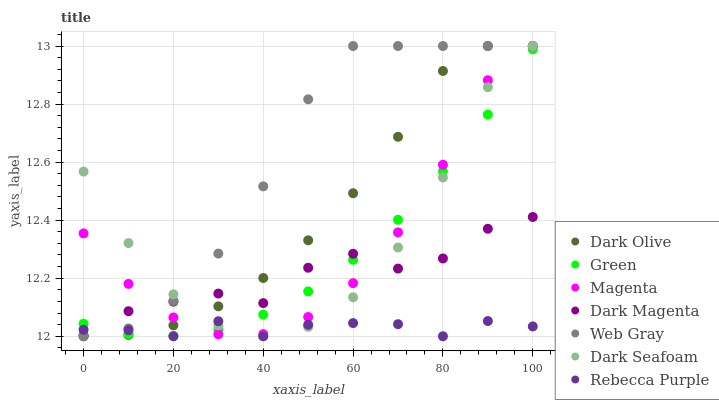Does Rebecca Purple have the minimum area under the curve?
Answer yes or no. Yes. Does Web Gray have the maximum area under the curve?
Answer yes or no. Yes. Does Dark Magenta have the minimum area under the curve?
Answer yes or no. No. Does Dark Magenta have the maximum area under the curve?
Answer yes or no. No. Is Green the smoothest?
Answer yes or no. Yes. Is Dark Seafoam the roughest?
Answer yes or no. Yes. Is Dark Magenta the smoothest?
Answer yes or no. No. Is Dark Magenta the roughest?
Answer yes or no. No. Does Dark Magenta have the lowest value?
Answer yes or no. Yes. Does Dark Olive have the lowest value?
Answer yes or no. No. Does Magenta have the highest value?
Answer yes or no. Yes. Does Dark Magenta have the highest value?
Answer yes or no. No. Does Dark Magenta intersect Rebecca Purple?
Answer yes or no. Yes. Is Dark Magenta less than Rebecca Purple?
Answer yes or no. No. Is Dark Magenta greater than Rebecca Purple?
Answer yes or no. No. 